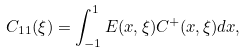<formula> <loc_0><loc_0><loc_500><loc_500>C _ { 1 1 } ( \xi ) = \int _ { - 1 } ^ { 1 } E ( x , \xi ) C ^ { + } ( x , \xi ) d x ,</formula> 